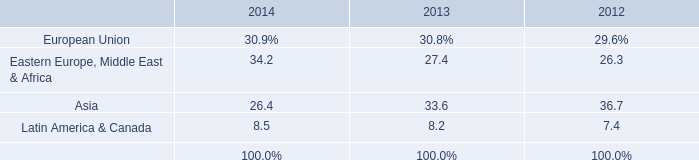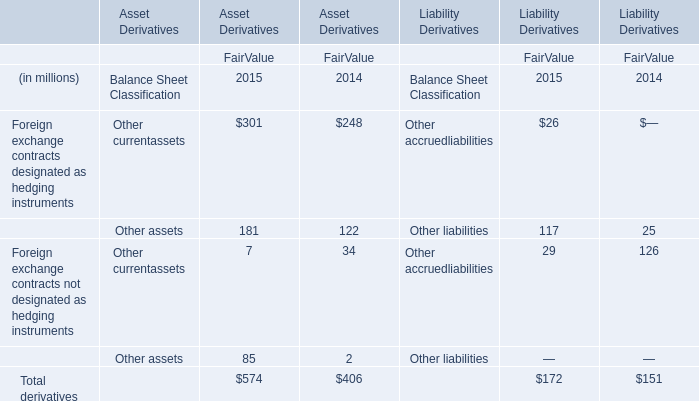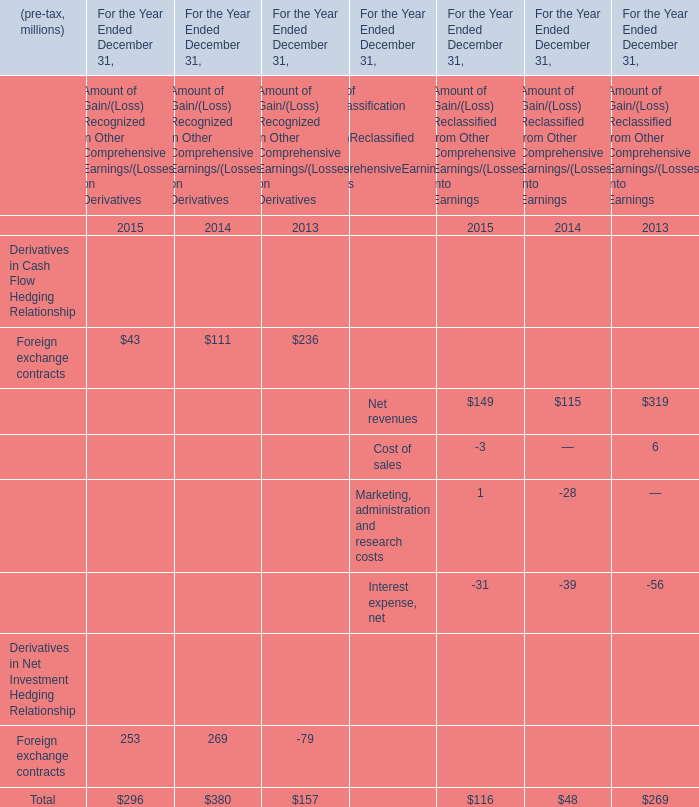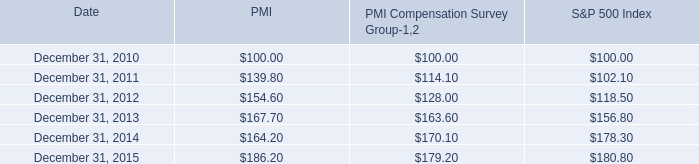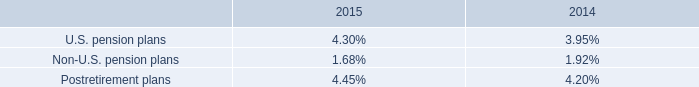What was the average value of the Total in the years where Foreign exchange contracts is positive? 
Computations: (((296 + 380) + 157) / 3)
Answer: 277.66667. 